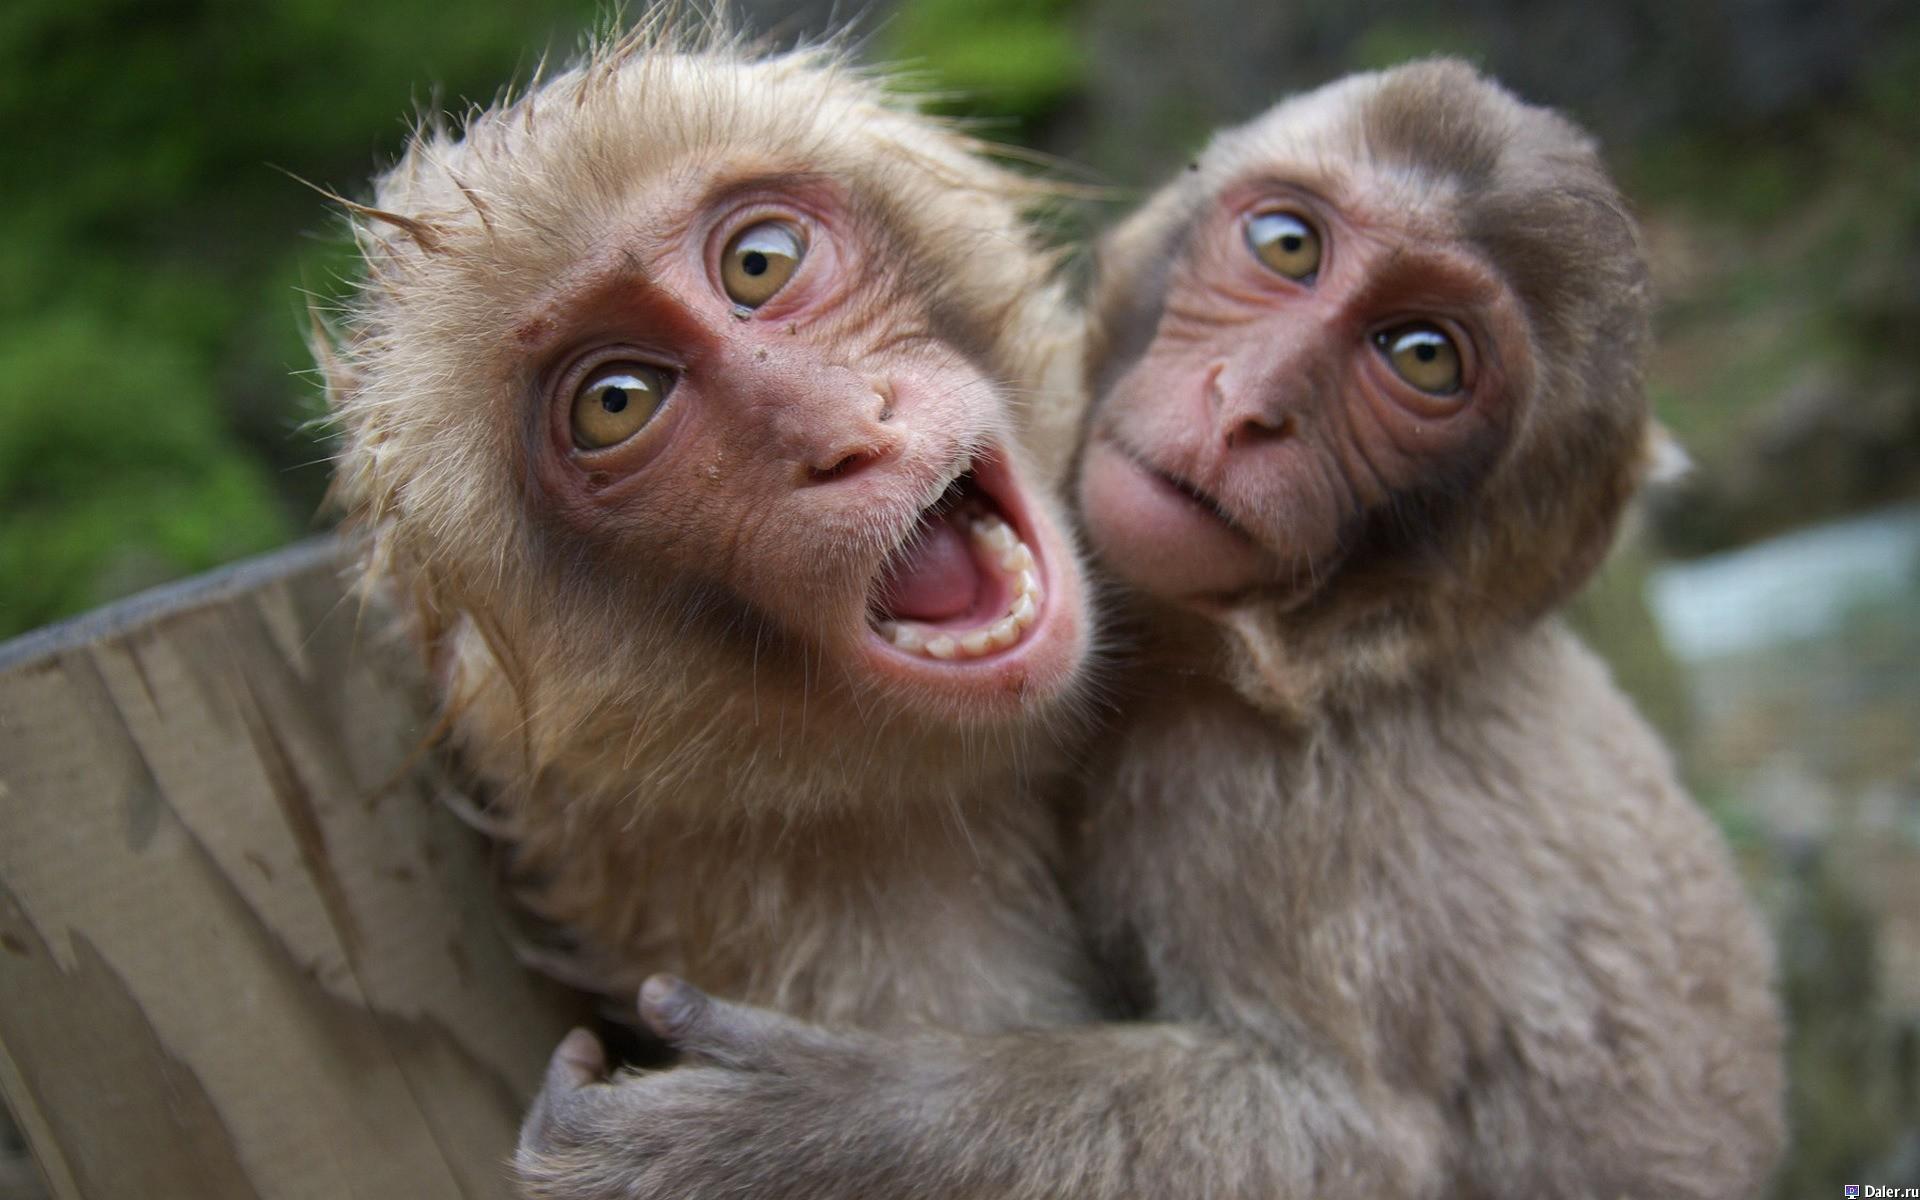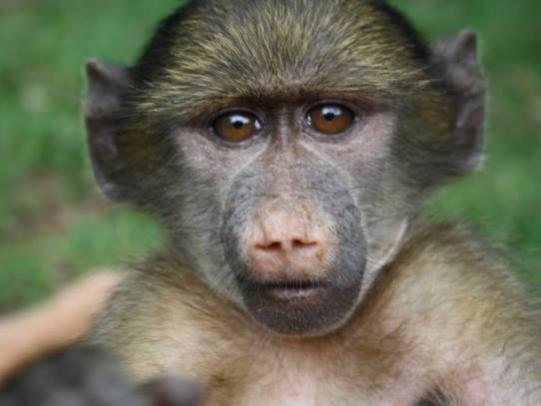The first image is the image on the left, the second image is the image on the right. Analyze the images presented: Is the assertion "The left image contains exactly two baboons." valid? Answer yes or no. Yes. The first image is the image on the left, the second image is the image on the right. Assess this claim about the two images: "A baboon is standing on all fours with its tail and pink rear angled toward the camera and its head turned.". Correct or not? Answer yes or no. No. 